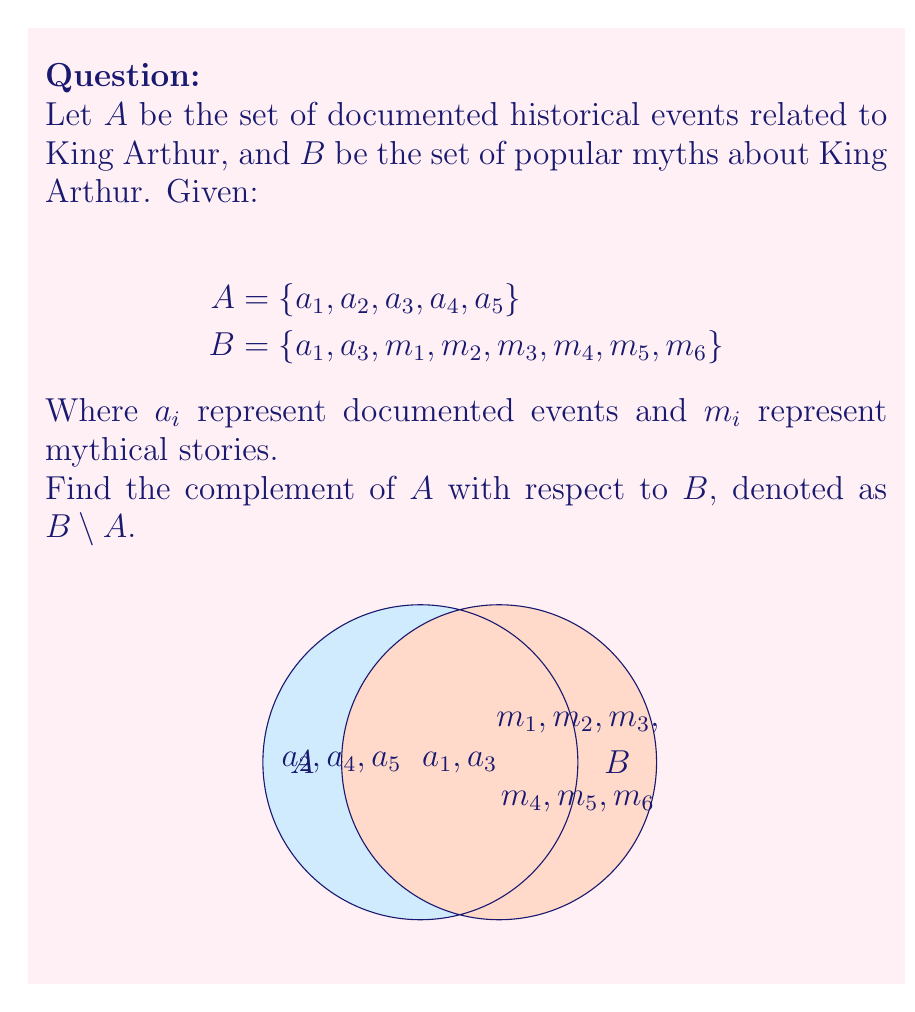Help me with this question. To find the complement of set $A$ with respect to set $B$, we need to identify all elements in $B$ that are not in $A$. Let's approach this step-by-step:

1) First, let's identify the elements that are in both $A$ and $B$:
   $A \cap B = \{a_1, a_3\}$

2) Now, we need to find all elements in $B$ that are not in this intersection:
   $B \setminus A = B \setminus (A \cap B)$

3) We can see that $B$ contains $\{a_1, a_3, m_1, m_2, m_3, m_4, m_5, m_6\}$

4) Removing $\{a_1, a_3\}$ from this set gives us the complement:
   $B \setminus A = \{m_1, m_2, m_3, m_4, m_5, m_6\}$

5) This set represents all the mythical stories about King Arthur that are not part of the documented historical events.

In set theory notation, we can write this as:
$$B \setminus A = \{x \in B | x \notin A\}$$

Which reads as "the set of all elements $x$ in $B$ such that $x$ is not in $A$".
Answer: $\{m_1, m_2, m_3, m_4, m_5, m_6\}$ 